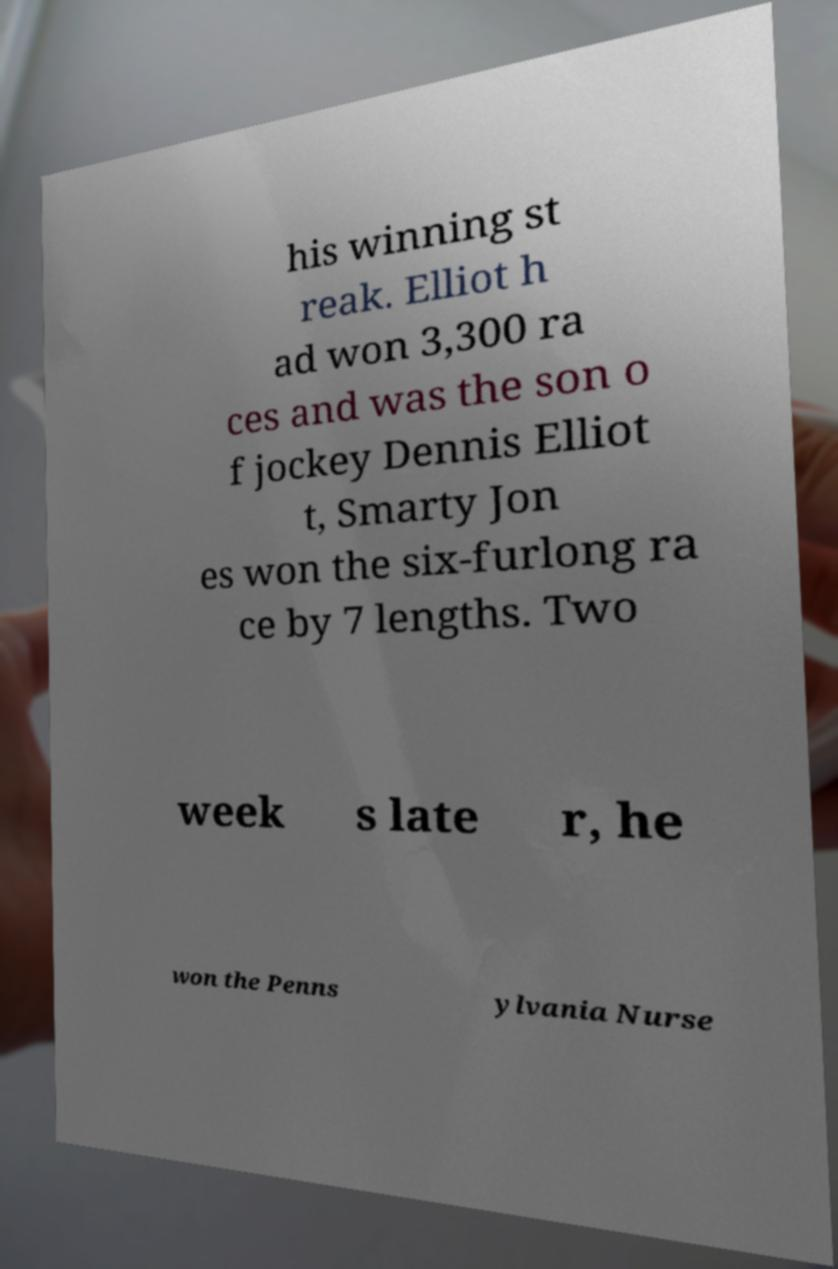Could you assist in decoding the text presented in this image and type it out clearly? his winning st reak. Elliot h ad won 3,300 ra ces and was the son o f jockey Dennis Elliot t, Smarty Jon es won the six-furlong ra ce by 7 lengths. Two week s late r, he won the Penns ylvania Nurse 